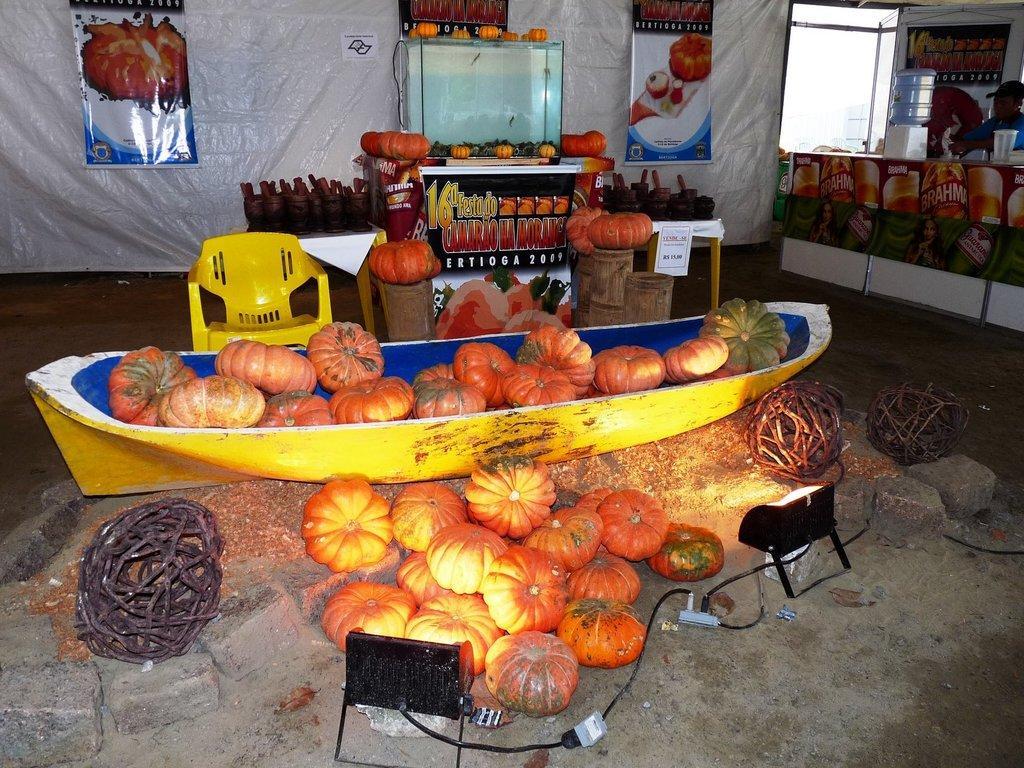Could you give a brief overview of what you see in this image? In the image there are many pumpkins on the floor and some are on the ship, in the back there is a table with pumpkins and fridge behind it, on the right side there is a water tin on the table with a person behind it in front of window, there are banners on the wall. 